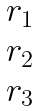<formula> <loc_0><loc_0><loc_500><loc_500>\begin{matrix} r _ { 1 } \\ r _ { 2 } \\ r _ { 3 } \\ \end{matrix}</formula> 